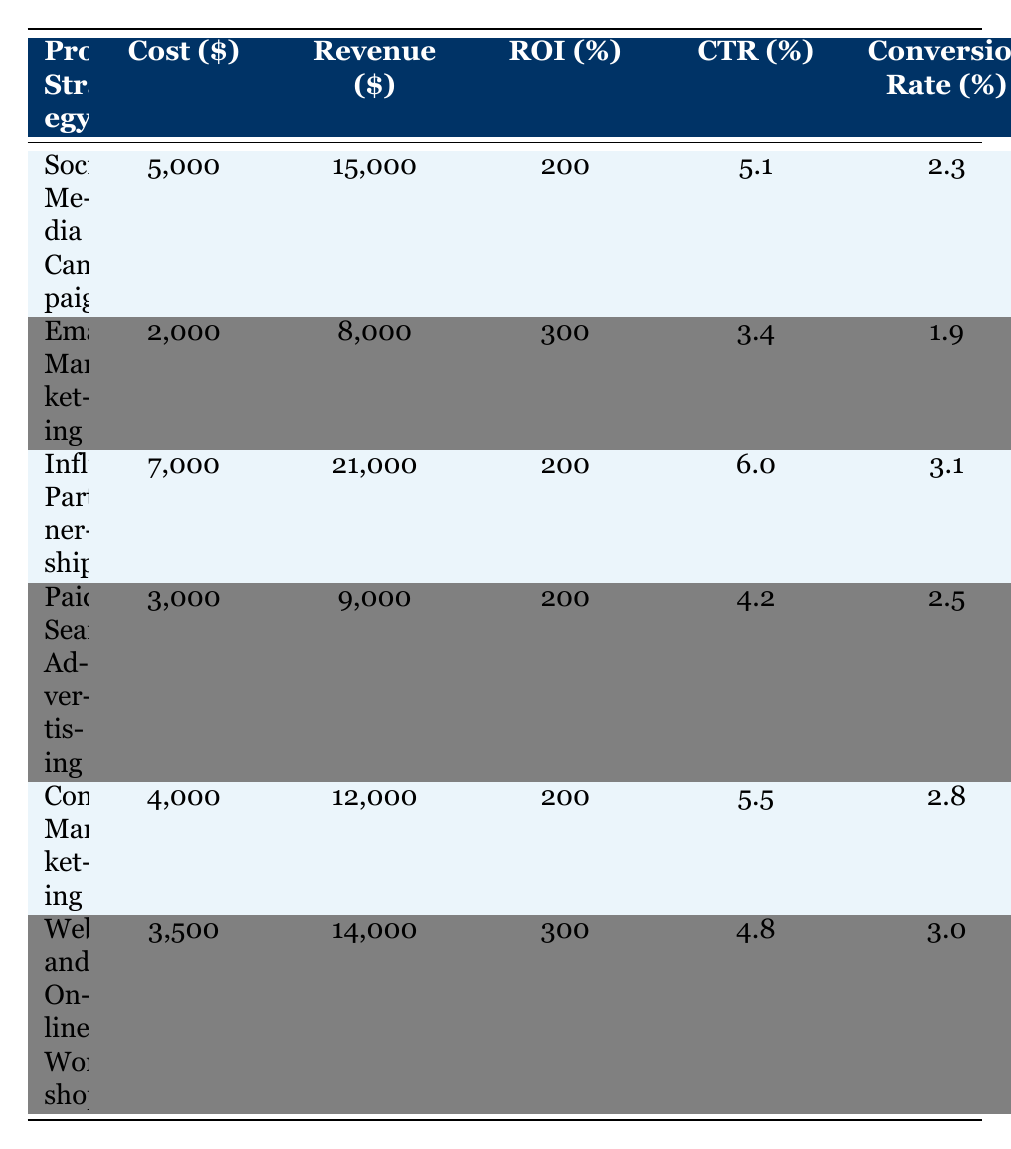What is the highest Return on Investment from the promotional strategies? The highest ROI is 300%, which can be found in the rows for "Email Marketing" and "Webinars and Online Workshops."
Answer: 300 What is the total cost of all promotional strategies combined? To find the total cost, add the costs from each strategy: 5000 + 2000 + 7000 + 3000 + 4000 + 3500 = 24500.
Answer: 24500 Which strategy has the lowest Click-Through Rate? By scanning the CTR column, "Email Marketing" has the lowest CTR at 3.4%.
Answer: 3.4 Are influencer partnerships more expensive than social media campaigns? Yes, influencer partnerships cost 7000, while social media campaigns cost 5000.
Answer: Yes What is the average ROI for all promotional strategies? To find the average ROI, sum the ROIs (200 + 300 + 200 + 200 + 200 + 300 = 1400) and divide by the number of strategies (6). 1400/6 = 233.33.
Answer: 233.33 How much revenue is generated from Paid Search Advertising? The revenue for Paid Search Advertising is listed as 9000.
Answer: 9000 Do all strategies have a Conversion Rate above 2%? No, "Email Marketing" has a Conversion Rate of 1.9%, which is below 2%.
Answer: No Which strategy has the highest revenue relative to its cost? To determine this, compare each strategy's revenue-to-cost ratio: Email Marketing (8000/2000 = 4), Webinars (14000/3500 = 4), both are the highest.
Answer: Email Marketing and Webinars What is the difference in Click-Through Rate between Influencer Partnerships and Webinars? Influencer Partnerships have a CTR of 6.0%, while Webinars have a CTR of 4.8%. The difference is 6.0 - 4.8 = 1.2.
Answer: 1.2 